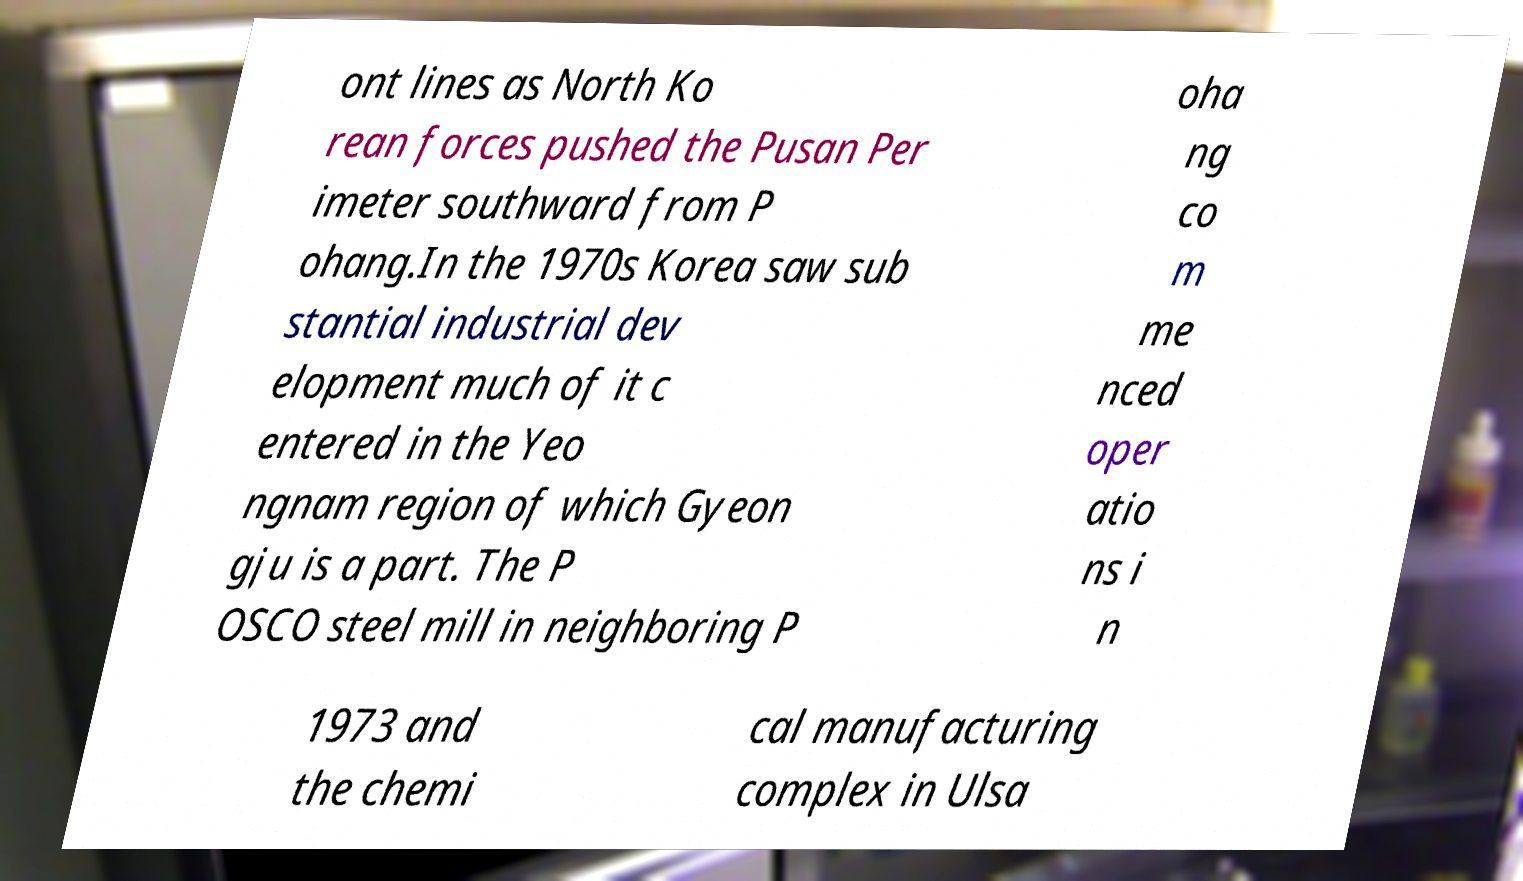Can you accurately transcribe the text from the provided image for me? ont lines as North Ko rean forces pushed the Pusan Per imeter southward from P ohang.In the 1970s Korea saw sub stantial industrial dev elopment much of it c entered in the Yeo ngnam region of which Gyeon gju is a part. The P OSCO steel mill in neighboring P oha ng co m me nced oper atio ns i n 1973 and the chemi cal manufacturing complex in Ulsa 